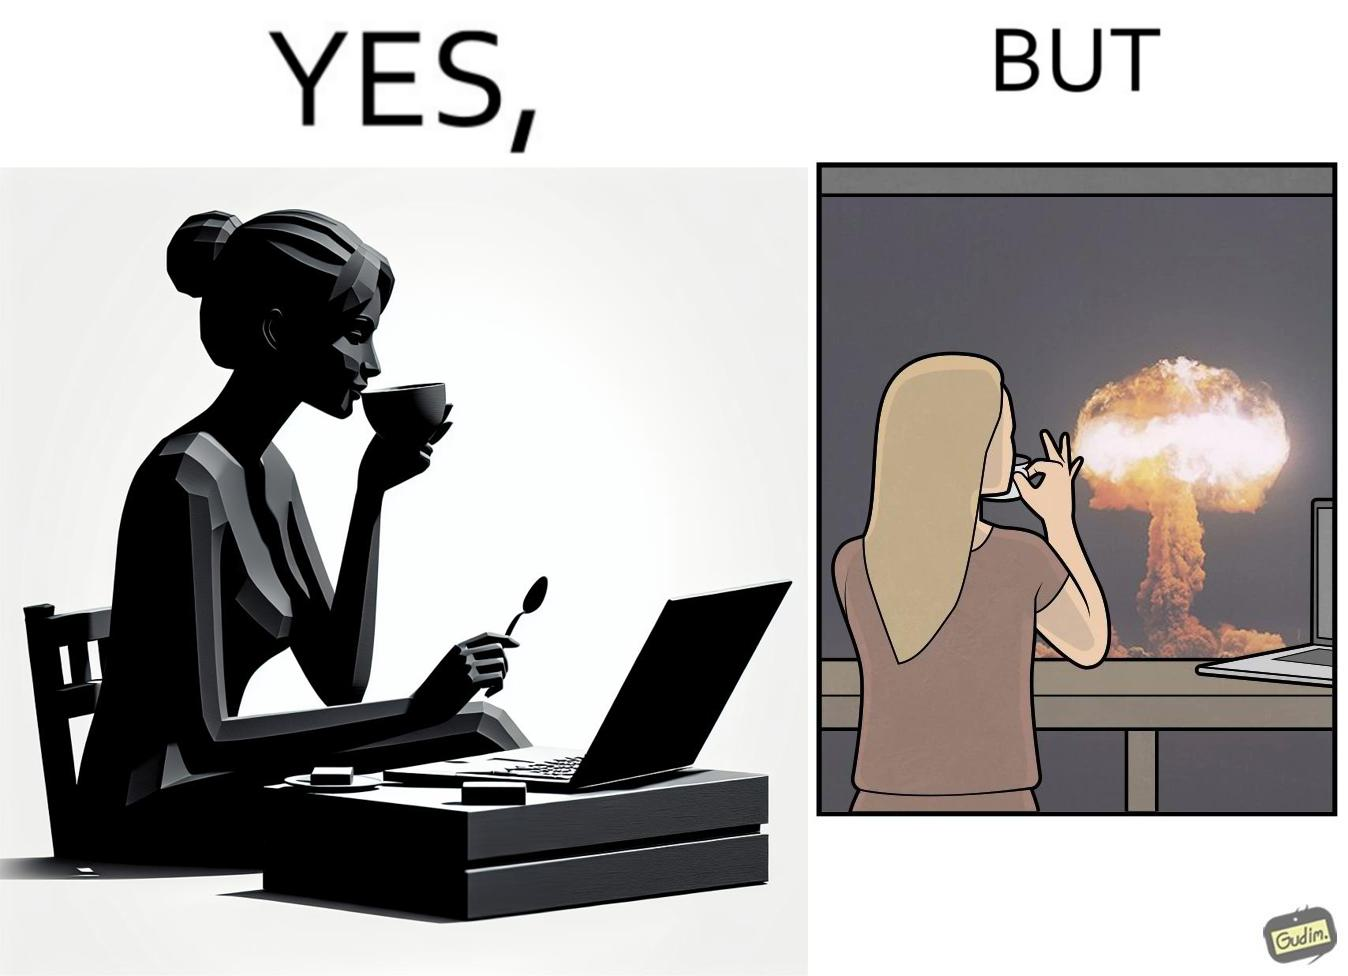Explain why this image is satirical. The images are funny since it shows a woman simply sipping from a cup at ease in a cafe with her laptop not caring about anything going on outside the cafe even though the situation is very grave,that is, a nuclear blast 